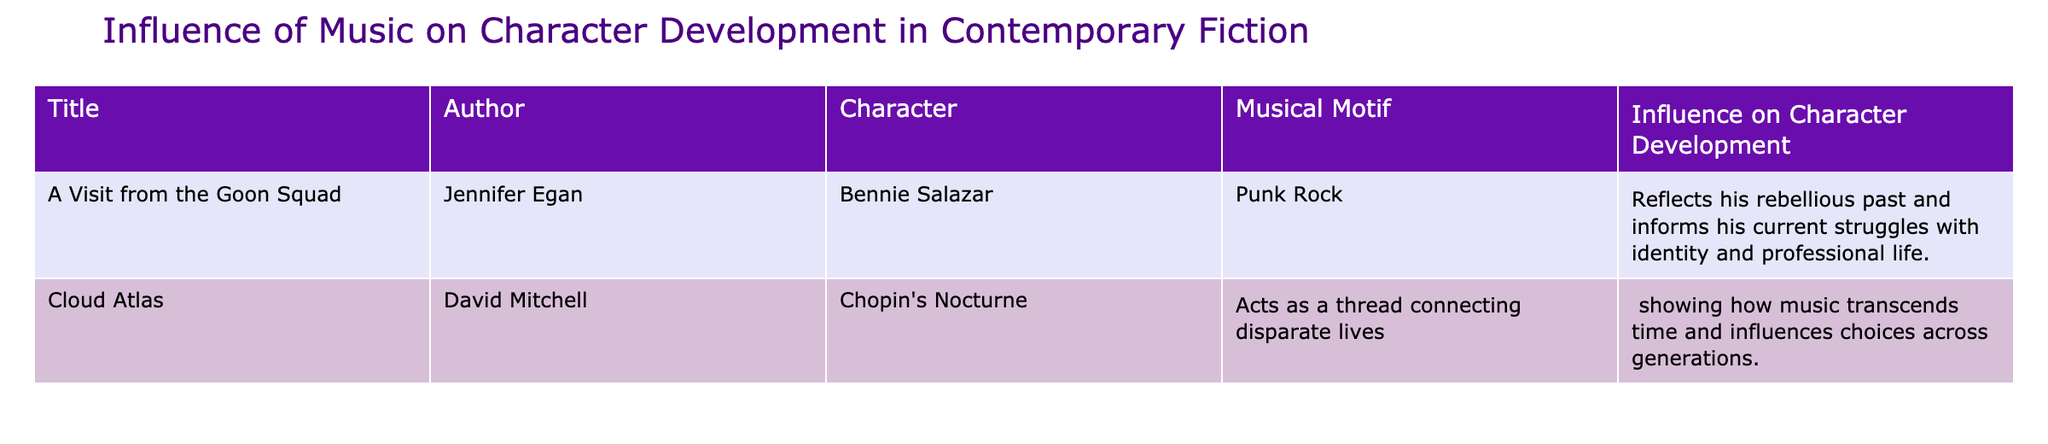What is the musical motif associated with Bennie Salazar? The table indicates that Bennie Salazar is associated with the musical motif "Punk Rock." This information can be directly retrieved from the column labeled "Musical Motif" corresponding to Bennie Salazar in the "Character" column.
Answer: Punk Rock How does music influence Bennie Salazar's character development? According to the table, the influence of music on Bennie Salazar's character development is that it reflects his rebellious past and informs his current struggles with identity and professional life. This detail is found in the "Influence on Character Development" column for Bennie Salazar.
Answer: Reflects his rebellious past Is there a character in the table whose musical motif is related to classical music? The table presents "Chopin's Nocturne" associated with a character in "Cloud Atlas." Since Chopin is a classical composer, this indicates that there is indeed a character whose musical motif is linked to classical music.
Answer: Yes Which character's musical motif acts as a thread connecting disparate lives? The character from the table whose musical motif acts as a thread connecting disparate lives is from "Cloud Atlas," specifically tied to "Chopin's Nocturne." This information can be deduced from the description of influence in the "Influence on Character Development" column.
Answer: Character from "Cloud Atlas" What is the total number of characters listed in the table? The table displays information for two characters, Bennie Salazar and the one from "Cloud Atlas." To ascertain the total, simply count the entries in the "Character" column, noting that there are two unique characters.
Answer: 2 Is the musical motif of Bennie Salazar the same as that of the character in "Cloud Atlas"? The table specifies that Bennie Salazar's musical motif is "Punk Rock," while the character from "Cloud Atlas" has the musical motif "Chopin's Nocturne." Since the two musical motifs differ, the answer is no.
Answer: No How many musical motifs linked to character development involve contemporary music genres? The table shows two characters: Bennie Salazar is linked to "Punk Rock," and the character from "Cloud Atlas" is associated with "Chopin's Nocturne." Only "Punk Rock" is a contemporary music genre. Therefore, the total count for contemporary genres is one.
Answer: 1 What are the names of the authors associated with the characters listed? From the table, Bennie Salazar is associated with Jennifer Egan, while the character from "Cloud Atlas" is associated with David Mitchell. These author names can be found in the "Author" column corresponding to each character.
Answer: Jennifer Egan and David Mitchell What is the influence of music on character development in "Cloud Atlas"? The table indicates that music in "Cloud Atlas," specifically Chopin's Nocturne, influences character development by showing how music transcends time and influences choices across generations. This influence can be found under the "Influence on Character Development" column specifically for the character in "Cloud Atlas."
Answer: Music transcends time and influences choices 